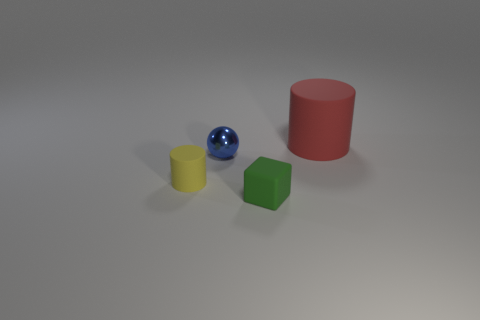Subtract all red cylinders. How many cylinders are left? 1 Subtract 0 yellow balls. How many objects are left? 4 Subtract all spheres. How many objects are left? 3 Subtract 1 cylinders. How many cylinders are left? 1 Subtract all yellow blocks. Subtract all yellow balls. How many blocks are left? 1 Subtract all gray cylinders. How many purple balls are left? 0 Subtract all tiny yellow matte cubes. Subtract all balls. How many objects are left? 3 Add 4 small yellow rubber cylinders. How many small yellow rubber cylinders are left? 5 Add 4 large things. How many large things exist? 5 Add 2 tiny blocks. How many objects exist? 6 